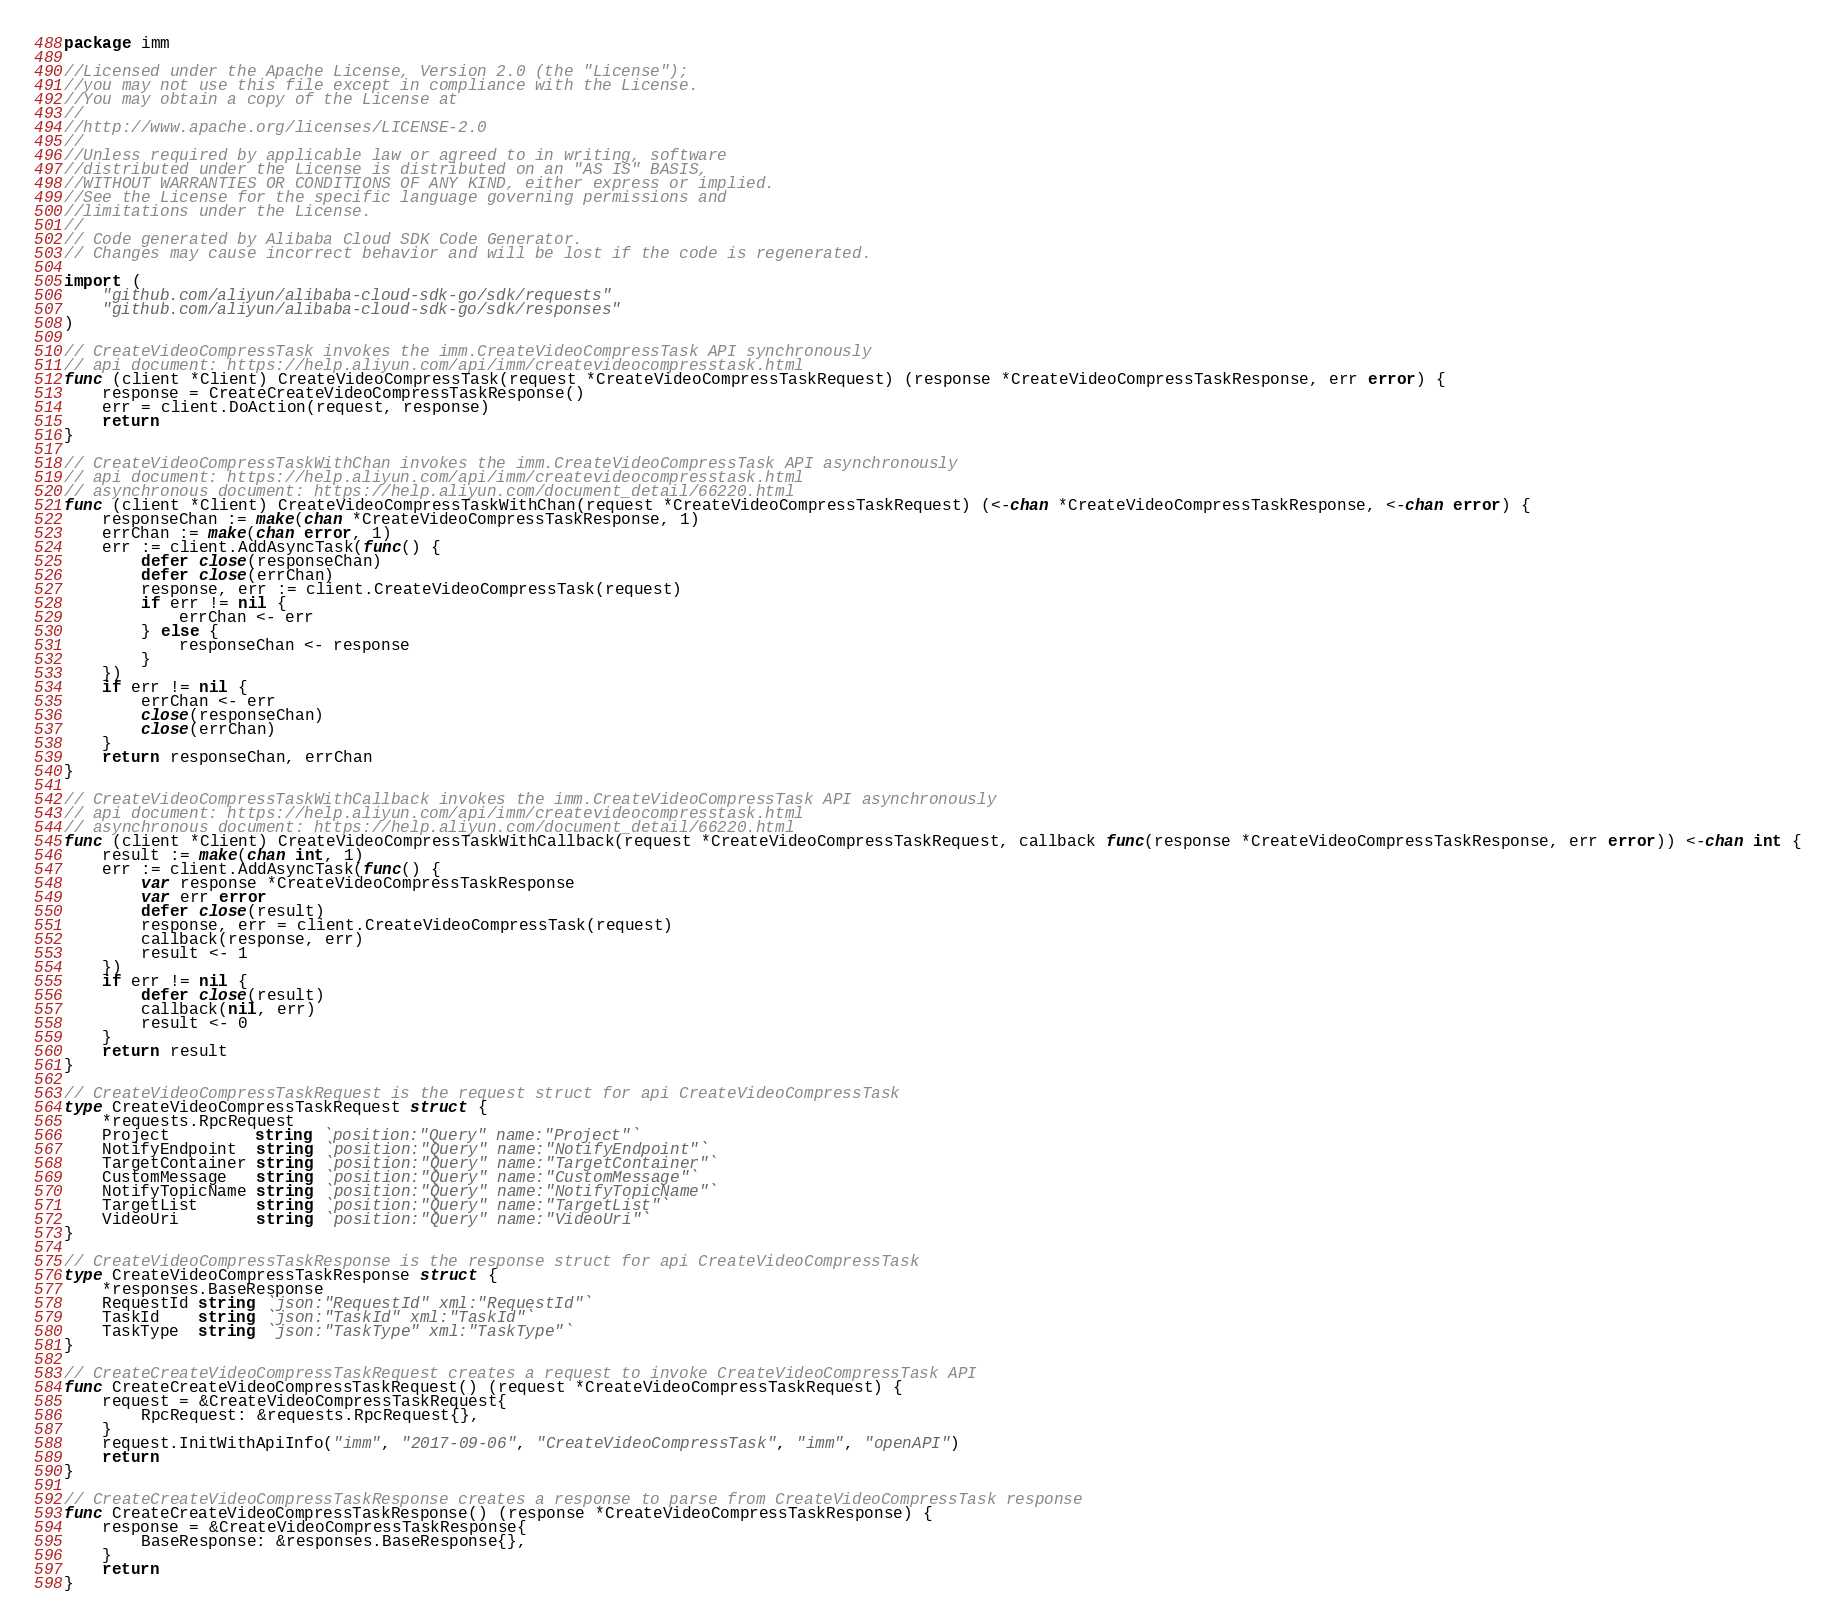<code> <loc_0><loc_0><loc_500><loc_500><_Go_>package imm

//Licensed under the Apache License, Version 2.0 (the "License");
//you may not use this file except in compliance with the License.
//You may obtain a copy of the License at
//
//http://www.apache.org/licenses/LICENSE-2.0
//
//Unless required by applicable law or agreed to in writing, software
//distributed under the License is distributed on an "AS IS" BASIS,
//WITHOUT WARRANTIES OR CONDITIONS OF ANY KIND, either express or implied.
//See the License for the specific language governing permissions and
//limitations under the License.
//
// Code generated by Alibaba Cloud SDK Code Generator.
// Changes may cause incorrect behavior and will be lost if the code is regenerated.

import (
	"github.com/aliyun/alibaba-cloud-sdk-go/sdk/requests"
	"github.com/aliyun/alibaba-cloud-sdk-go/sdk/responses"
)

// CreateVideoCompressTask invokes the imm.CreateVideoCompressTask API synchronously
// api document: https://help.aliyun.com/api/imm/createvideocompresstask.html
func (client *Client) CreateVideoCompressTask(request *CreateVideoCompressTaskRequest) (response *CreateVideoCompressTaskResponse, err error) {
	response = CreateCreateVideoCompressTaskResponse()
	err = client.DoAction(request, response)
	return
}

// CreateVideoCompressTaskWithChan invokes the imm.CreateVideoCompressTask API asynchronously
// api document: https://help.aliyun.com/api/imm/createvideocompresstask.html
// asynchronous document: https://help.aliyun.com/document_detail/66220.html
func (client *Client) CreateVideoCompressTaskWithChan(request *CreateVideoCompressTaskRequest) (<-chan *CreateVideoCompressTaskResponse, <-chan error) {
	responseChan := make(chan *CreateVideoCompressTaskResponse, 1)
	errChan := make(chan error, 1)
	err := client.AddAsyncTask(func() {
		defer close(responseChan)
		defer close(errChan)
		response, err := client.CreateVideoCompressTask(request)
		if err != nil {
			errChan <- err
		} else {
			responseChan <- response
		}
	})
	if err != nil {
		errChan <- err
		close(responseChan)
		close(errChan)
	}
	return responseChan, errChan
}

// CreateVideoCompressTaskWithCallback invokes the imm.CreateVideoCompressTask API asynchronously
// api document: https://help.aliyun.com/api/imm/createvideocompresstask.html
// asynchronous document: https://help.aliyun.com/document_detail/66220.html
func (client *Client) CreateVideoCompressTaskWithCallback(request *CreateVideoCompressTaskRequest, callback func(response *CreateVideoCompressTaskResponse, err error)) <-chan int {
	result := make(chan int, 1)
	err := client.AddAsyncTask(func() {
		var response *CreateVideoCompressTaskResponse
		var err error
		defer close(result)
		response, err = client.CreateVideoCompressTask(request)
		callback(response, err)
		result <- 1
	})
	if err != nil {
		defer close(result)
		callback(nil, err)
		result <- 0
	}
	return result
}

// CreateVideoCompressTaskRequest is the request struct for api CreateVideoCompressTask
type CreateVideoCompressTaskRequest struct {
	*requests.RpcRequest
	Project         string `position:"Query" name:"Project"`
	NotifyEndpoint  string `position:"Query" name:"NotifyEndpoint"`
	TargetContainer string `position:"Query" name:"TargetContainer"`
	CustomMessage   string `position:"Query" name:"CustomMessage"`
	NotifyTopicName string `position:"Query" name:"NotifyTopicName"`
	TargetList      string `position:"Query" name:"TargetList"`
	VideoUri        string `position:"Query" name:"VideoUri"`
}

// CreateVideoCompressTaskResponse is the response struct for api CreateVideoCompressTask
type CreateVideoCompressTaskResponse struct {
	*responses.BaseResponse
	RequestId string `json:"RequestId" xml:"RequestId"`
	TaskId    string `json:"TaskId" xml:"TaskId"`
	TaskType  string `json:"TaskType" xml:"TaskType"`
}

// CreateCreateVideoCompressTaskRequest creates a request to invoke CreateVideoCompressTask API
func CreateCreateVideoCompressTaskRequest() (request *CreateVideoCompressTaskRequest) {
	request = &CreateVideoCompressTaskRequest{
		RpcRequest: &requests.RpcRequest{},
	}
	request.InitWithApiInfo("imm", "2017-09-06", "CreateVideoCompressTask", "imm", "openAPI")
	return
}

// CreateCreateVideoCompressTaskResponse creates a response to parse from CreateVideoCompressTask response
func CreateCreateVideoCompressTaskResponse() (response *CreateVideoCompressTaskResponse) {
	response = &CreateVideoCompressTaskResponse{
		BaseResponse: &responses.BaseResponse{},
	}
	return
}
</code> 